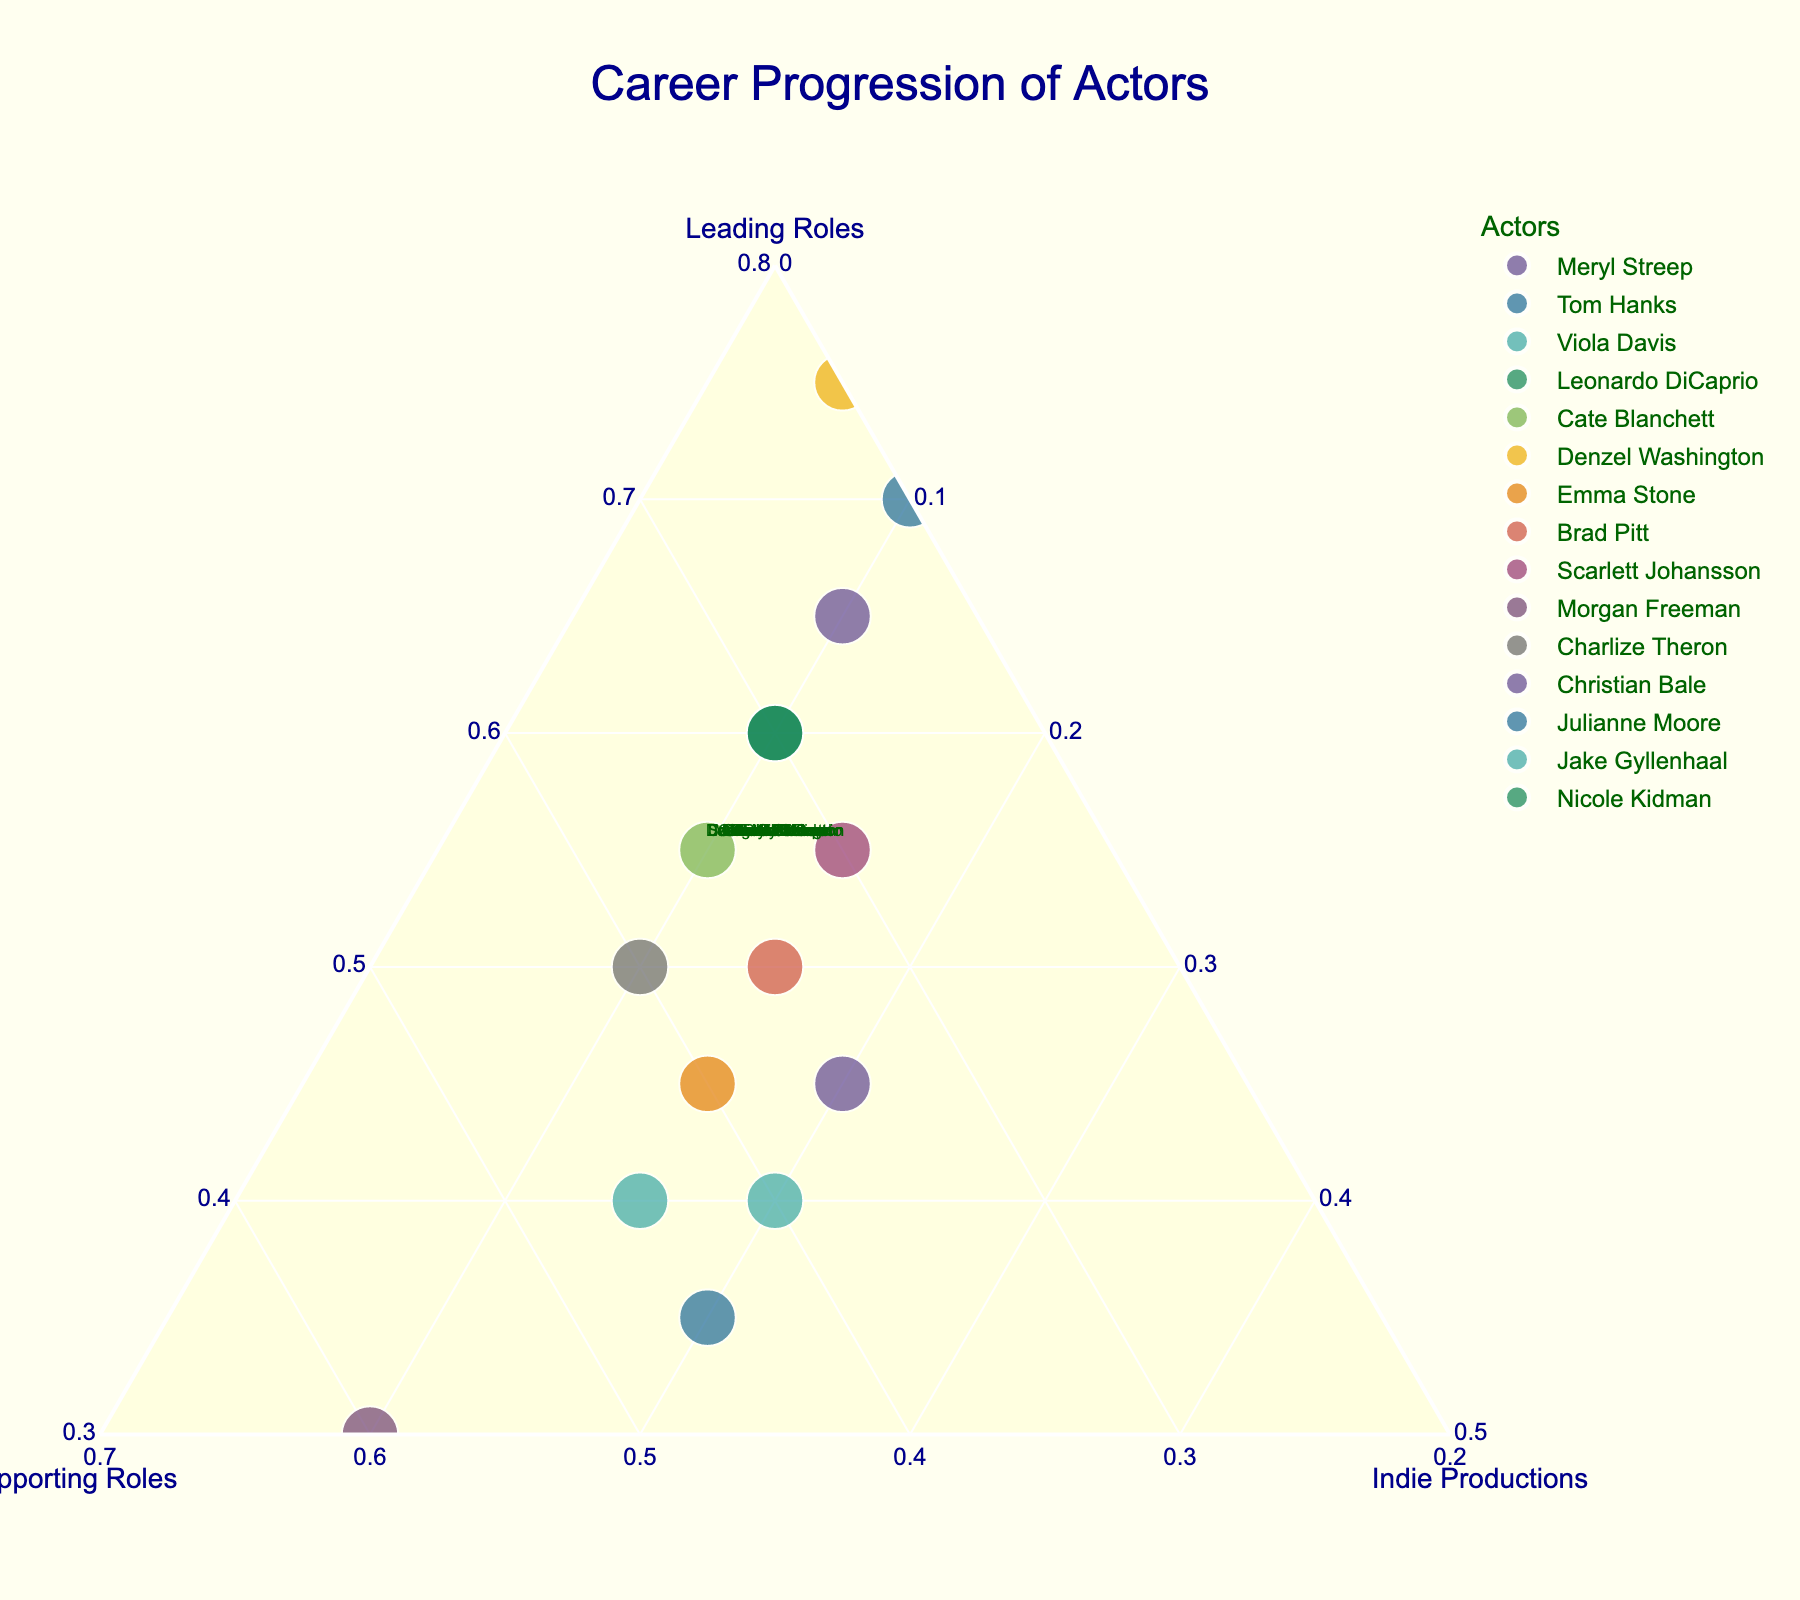What's the title of the plot? The title of the plot is usually displayed at the top of the figure. Here, the title reads "Career Progression of Actors".
Answer: Career Progression of Actors How many actors are represented in the plot? Each data point in the ternary plot represents an actor. To find the total number of actors, count the number of individual points/annotations. In this case, there are 15 actors in the dataset.
Answer: 15 Which actor has the highest percentage of time spent in Leading Roles? Locate the actor closest to the "Leading Roles" vertex in the ternary plot. The vertex with the highest Leading Roles percentage is at 75%, which corresponds to Denzel Washington.
Answer: Denzel Washington What is the median percentage of time spent in Supporting Roles by these actors? To find the median, list all the Supporting Roles percentages in ascending order and identify the middle value. The percentages are: 20, 20, 20, 25, 30, 30, 30, 35, 35, 35, 40, 40, 40, 45, 60. The middle value (the 8th value) is 35%.
Answer: 35% Who has spent an equal percentage of time in Leading Roles and Supporting Roles? Look for the point on the plot where the percentages for Leading Roles and Supporting Roles are equal. Jake Gyllenhaal has spent 40% of his career in both Leading Roles and Supporting Roles.
Answer: Jake Gyllenhaal Which actors have dedicated the least percentage of their career to Indie Productions? Locate the actors closest to the "Indie Productions" vertex with the lowest values. Denzel Washington (5%) and Morgan Freeman (10%) are the lowest, but Denzel Washington has the absolute lowest.
Answer: Denzel Washington How does the career progression of Emma Stone compare to Brad Pitt in terms of Supporting Roles? Compare the percentage of time spent in Supporting Roles for both actors by looking at the b-axis (Supporting Roles). Emma Stone has spent 40% while Brad Pitt has spent 35%.
Answer: Emma Stone has more What is the combined percentage of Leading Roles and Indie Productions for Charlize Theron? Add the percentage of Leading Roles and Indie Productions for Charlize Theron: Leading Roles (50%) + Indie Productions (10%) = 60%.
Answer: 60% Which actor shows the most balanced career across all three types of roles? Look for a data point roughly in the center of the ternary plot, equally distant from all vertices. Julianne Moore with 35% Leading Roles, 45% Supporting Roles, and 20% Indie Productions is quite balanced.
Answer: Julianne Moore Is there any actor who has more than 70% of their career in one category? Examine each data point and its position relative to the vertices. Only Denzel Washington (75% in Leading Roles) and Tom Hanks (70% in Leading Roles) fit this criterion.
Answer: Denzel Washington, Tom Hanks 